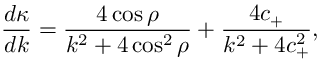<formula> <loc_0><loc_0><loc_500><loc_500>\frac { d \kappa } { d k } = \frac { 4 \cos \rho } { k ^ { 2 } + 4 \cos ^ { 2 } \rho } + \frac { 4 c _ { + } } { k ^ { 2 } + 4 c _ { + } ^ { 2 } } ,</formula> 